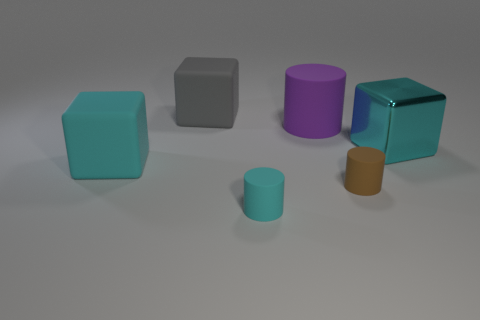What number of other cubes have the same color as the metal block?
Your answer should be compact. 1. There is a big matte object that is in front of the big cylinder; is it the same shape as the cyan object that is behind the cyan rubber cube?
Ensure brevity in your answer.  Yes. Are there any blue things that have the same size as the cyan metallic block?
Your answer should be very brief. No. There is a large cyan cube that is left of the big metal cube; what material is it?
Provide a succinct answer. Rubber. Is the big thing in front of the large cyan metallic object made of the same material as the large gray cube?
Make the answer very short. Yes. Are any tiny things visible?
Offer a very short reply. Yes. What color is the other tiny thing that is the same material as the brown thing?
Keep it short and to the point. Cyan. The big block to the left of the big rubber cube that is behind the large cyan object that is on the left side of the large gray cube is what color?
Your answer should be compact. Cyan. Does the cyan shiny thing have the same size as the purple thing that is in front of the gray thing?
Provide a succinct answer. Yes. How many things are large matte things that are on the left side of the large gray rubber object or big things that are on the left side of the big gray block?
Your answer should be very brief. 1. 